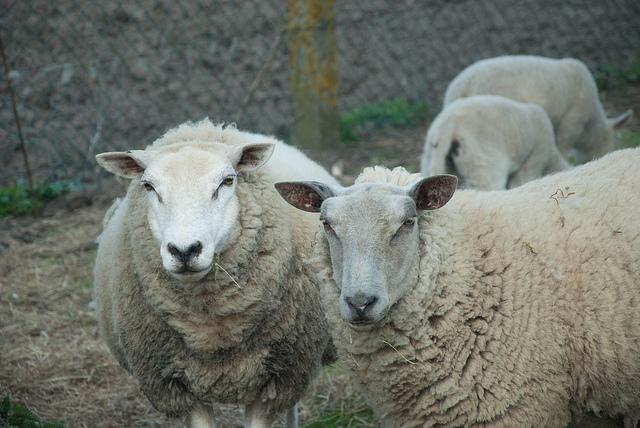What color are the lambs?
Quick response, please. White. How many animals are in the picture?
Short answer required. 4. Are these goats?
Quick response, please. No. Are both sheep's ears tagged?
Give a very brief answer. No. Is it possible to utilize this animals fur for clothing?
Concise answer only. Yes. How many animals are pictured?
Quick response, please. 4. When was the last time these sheep were sheared?
Concise answer only. Month ago. 